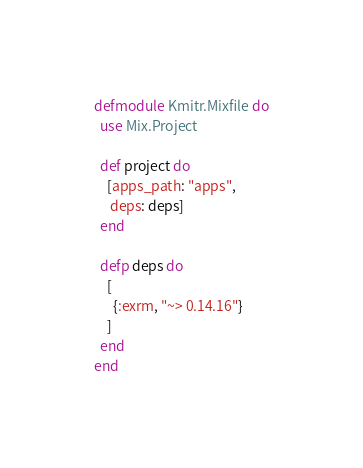<code> <loc_0><loc_0><loc_500><loc_500><_Elixir_>defmodule Kmitr.Mixfile do
  use Mix.Project

  def project do
    [apps_path: "apps",
     deps: deps]
  end

  defp deps do
    [
      {:exrm, "~> 0.14.16"}
    ]
  end
end
</code> 